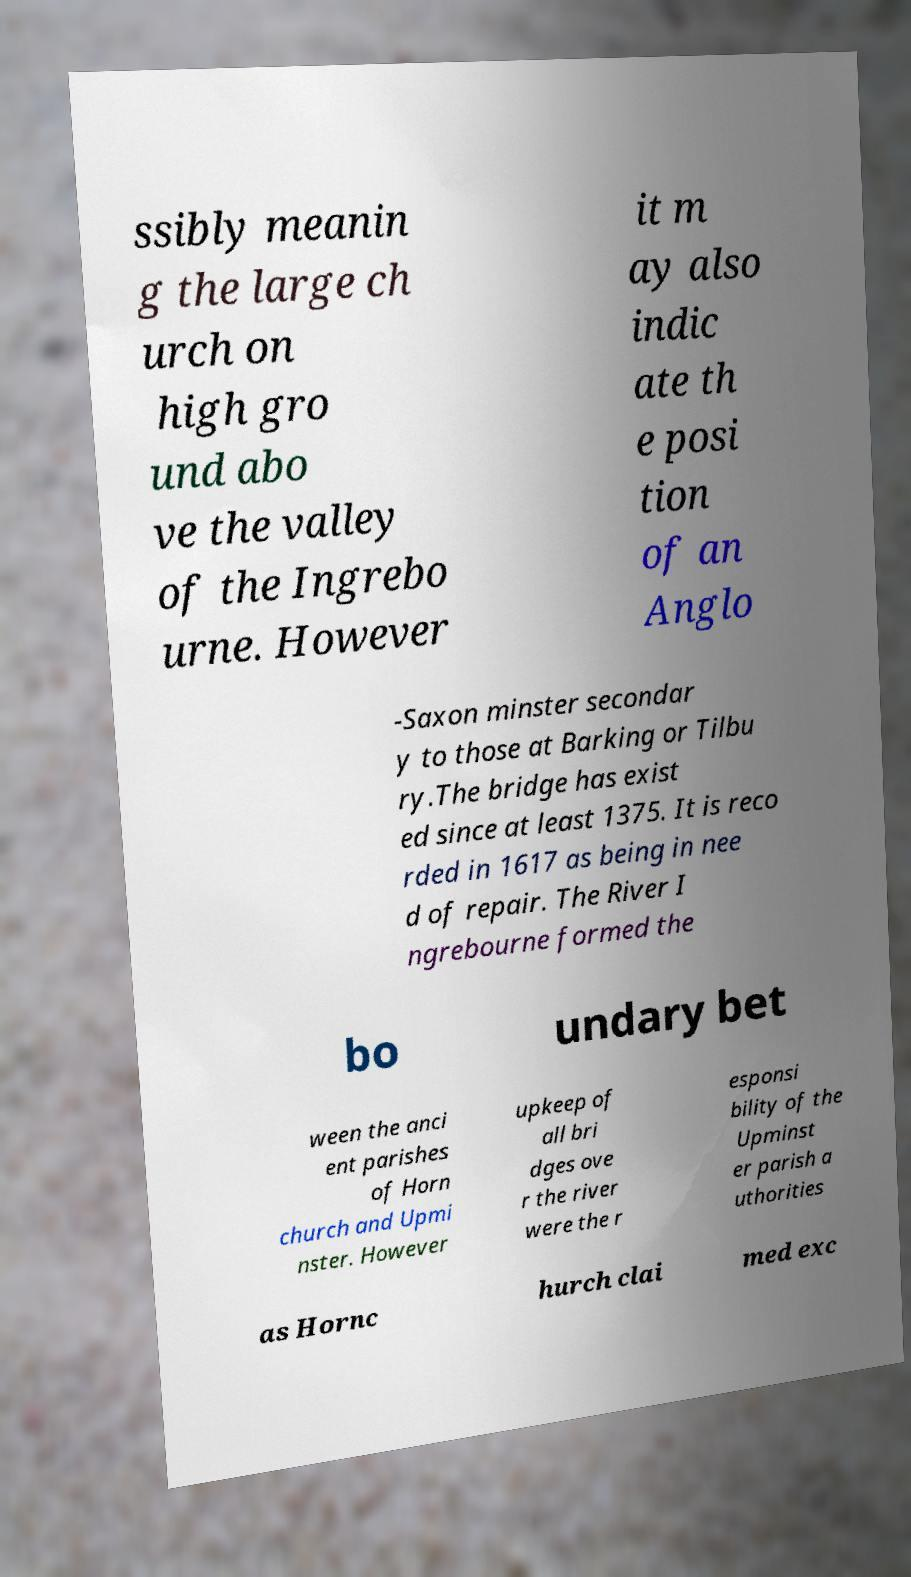I need the written content from this picture converted into text. Can you do that? ssibly meanin g the large ch urch on high gro und abo ve the valley of the Ingrebo urne. However it m ay also indic ate th e posi tion of an Anglo -Saxon minster secondar y to those at Barking or Tilbu ry.The bridge has exist ed since at least 1375. It is reco rded in 1617 as being in nee d of repair. The River I ngrebourne formed the bo undary bet ween the anci ent parishes of Horn church and Upmi nster. However upkeep of all bri dges ove r the river were the r esponsi bility of the Upminst er parish a uthorities as Hornc hurch clai med exc 